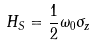<formula> <loc_0><loc_0><loc_500><loc_500>H _ { S } = \frac { 1 } { 2 } \omega _ { 0 } \sigma _ { z }</formula> 